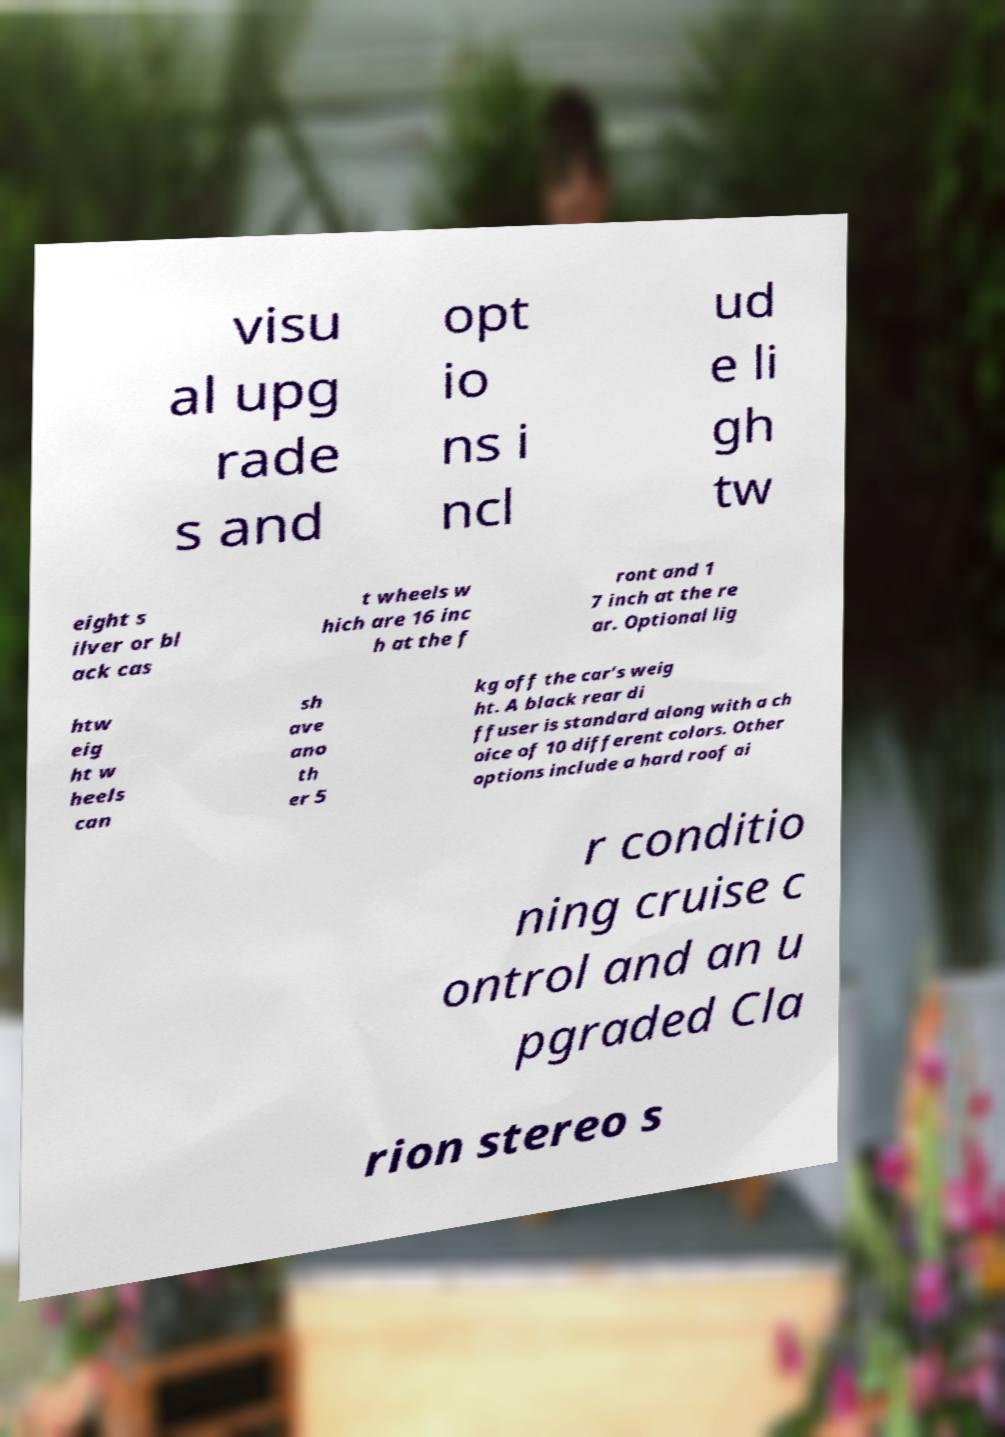I need the written content from this picture converted into text. Can you do that? visu al upg rade s and opt io ns i ncl ud e li gh tw eight s ilver or bl ack cas t wheels w hich are 16 inc h at the f ront and 1 7 inch at the re ar. Optional lig htw eig ht w heels can sh ave ano th er 5 kg off the car’s weig ht. A black rear di ffuser is standard along with a ch oice of 10 different colors. Other options include a hard roof ai r conditio ning cruise c ontrol and an u pgraded Cla rion stereo s 